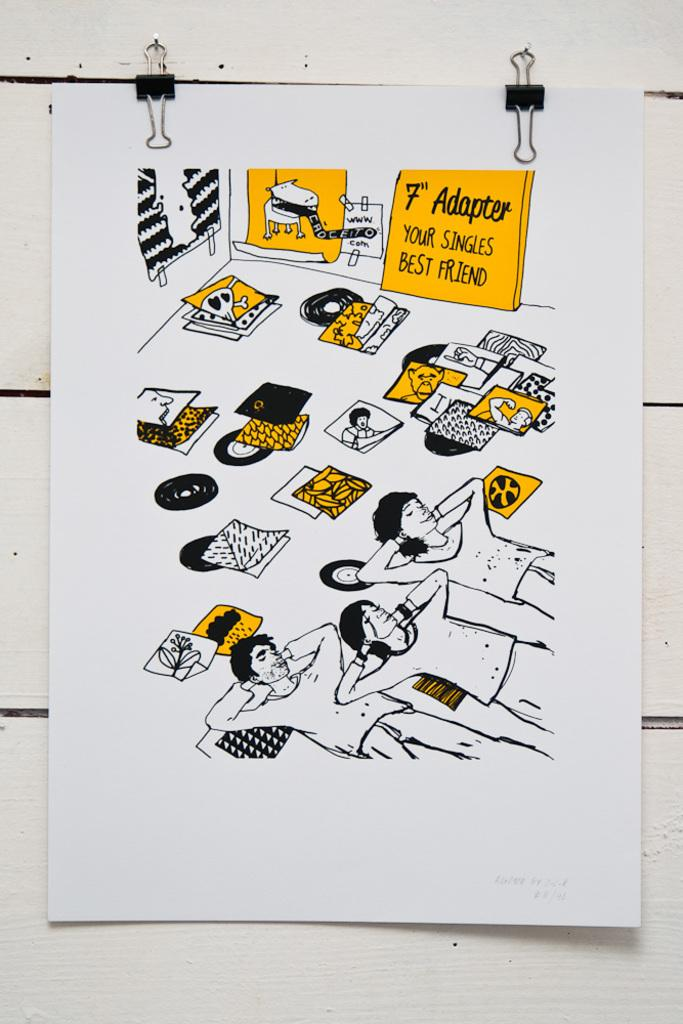Provide a one-sentence caption for the provided image. A bunch of vinyl records on the floor with a sign that says "7" Adapter" on it. 